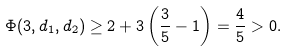Convert formula to latex. <formula><loc_0><loc_0><loc_500><loc_500>\Phi ( 3 , d _ { 1 } , d _ { 2 } ) \geq 2 + 3 \left ( \frac { 3 } { 5 } - 1 \right ) = \frac { 4 } { 5 } > 0 .</formula> 